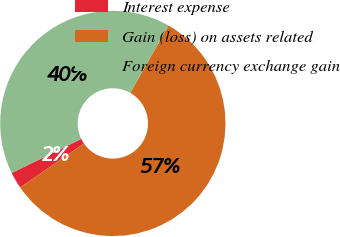Convert chart to OTSL. <chart><loc_0><loc_0><loc_500><loc_500><pie_chart><fcel>Interest expense<fcel>Gain (loss) on assets related<fcel>Foreign currency exchange gain<nl><fcel>2.38%<fcel>57.14%<fcel>40.48%<nl></chart> 